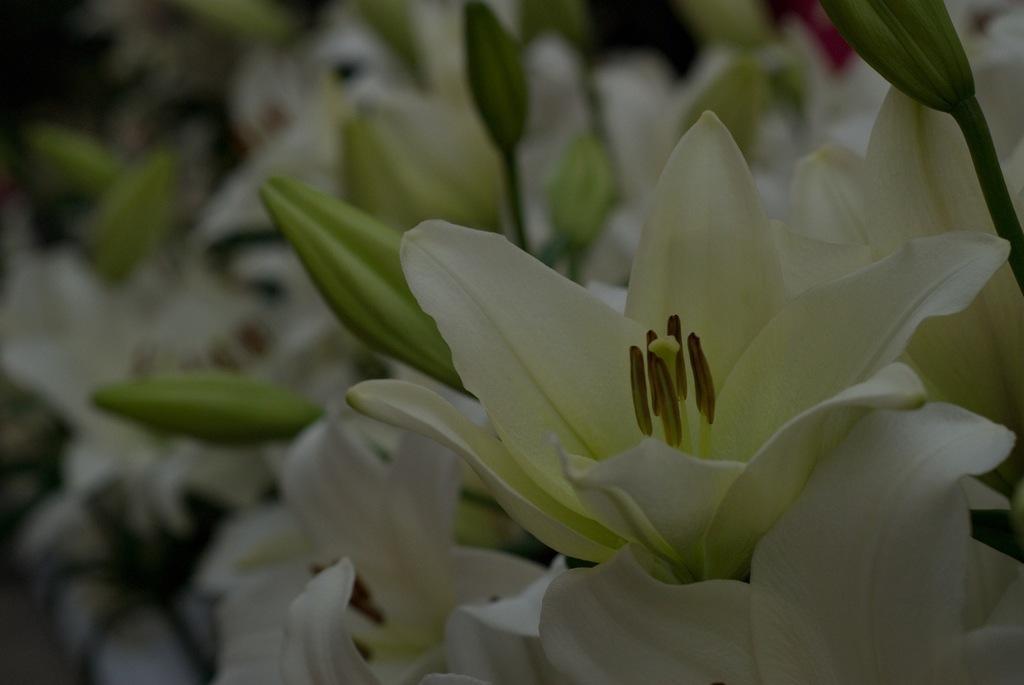Describe this image in one or two sentences. This picture might be taken from outside of the city. In this image, on the right side, we can see a flower. In the background, we can see some buds and green color. 